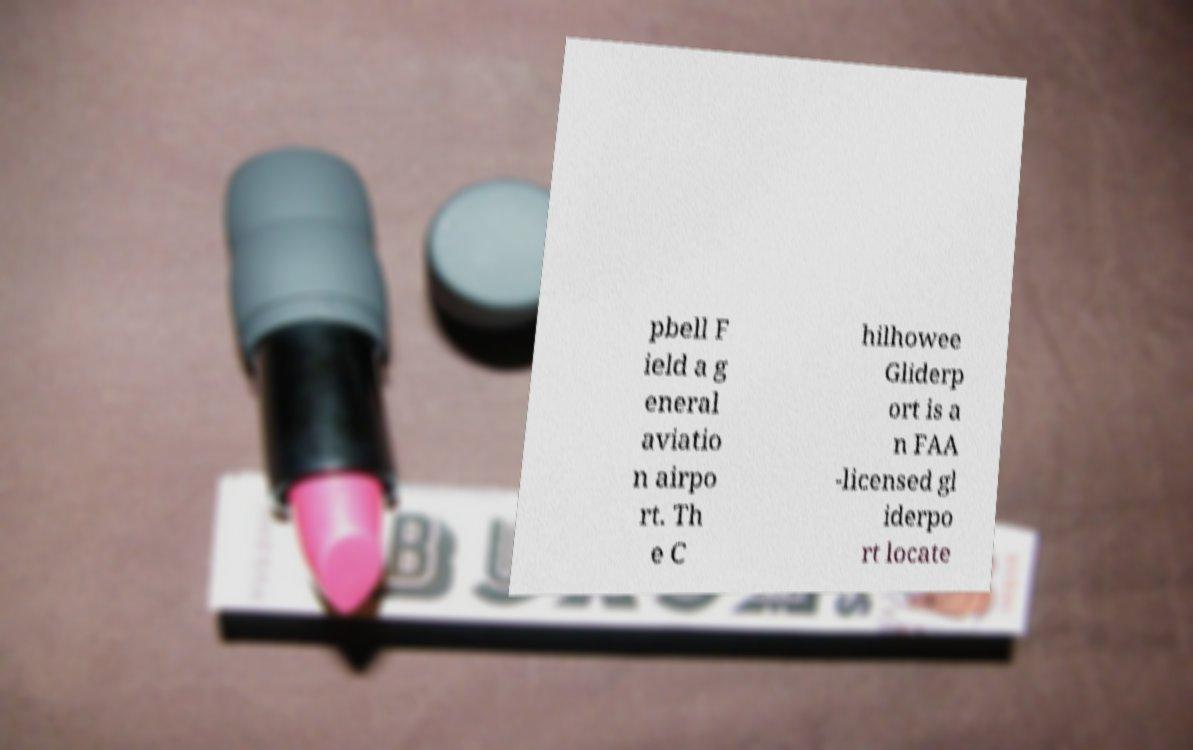Can you accurately transcribe the text from the provided image for me? pbell F ield a g eneral aviatio n airpo rt. Th e C hilhowee Gliderp ort is a n FAA -licensed gl iderpo rt locate 